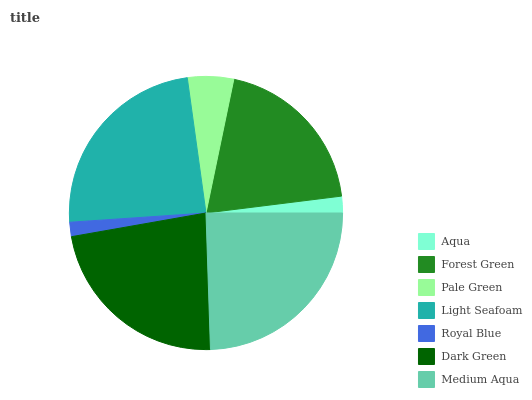Is Royal Blue the minimum?
Answer yes or no. Yes. Is Medium Aqua the maximum?
Answer yes or no. Yes. Is Forest Green the minimum?
Answer yes or no. No. Is Forest Green the maximum?
Answer yes or no. No. Is Forest Green greater than Aqua?
Answer yes or no. Yes. Is Aqua less than Forest Green?
Answer yes or no. Yes. Is Aqua greater than Forest Green?
Answer yes or no. No. Is Forest Green less than Aqua?
Answer yes or no. No. Is Forest Green the high median?
Answer yes or no. Yes. Is Forest Green the low median?
Answer yes or no. Yes. Is Aqua the high median?
Answer yes or no. No. Is Light Seafoam the low median?
Answer yes or no. No. 